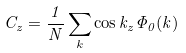<formula> <loc_0><loc_0><loc_500><loc_500>C _ { z } = \frac { 1 } { N } \sum _ { k } \cos { k _ { z } } \Phi _ { 0 } ( k )</formula> 